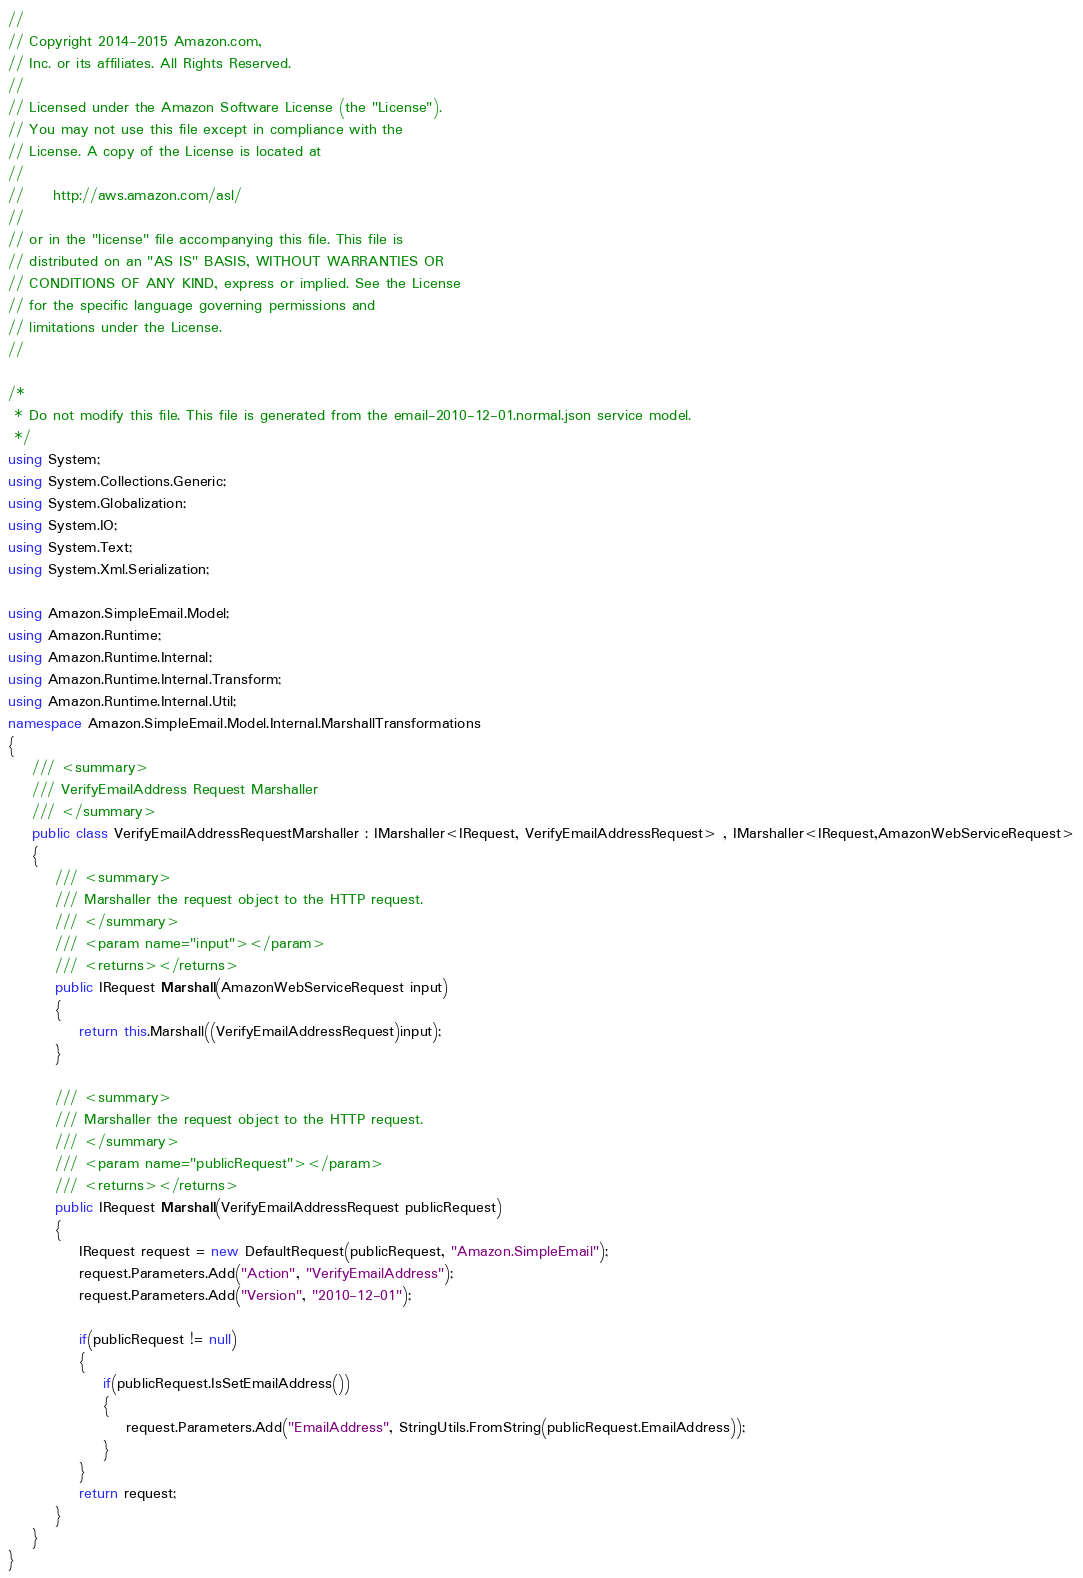Convert code to text. <code><loc_0><loc_0><loc_500><loc_500><_C#_>//
// Copyright 2014-2015 Amazon.com, 
// Inc. or its affiliates. All Rights Reserved.
// 
// Licensed under the Amazon Software License (the "License"). 
// You may not use this file except in compliance with the 
// License. A copy of the License is located at
// 
//     http://aws.amazon.com/asl/
// 
// or in the "license" file accompanying this file. This file is 
// distributed on an "AS IS" BASIS, WITHOUT WARRANTIES OR 
// CONDITIONS OF ANY KIND, express or implied. See the License 
// for the specific language governing permissions and 
// limitations under the License.
//

/*
 * Do not modify this file. This file is generated from the email-2010-12-01.normal.json service model.
 */
using System;
using System.Collections.Generic;
using System.Globalization;
using System.IO;
using System.Text;
using System.Xml.Serialization;

using Amazon.SimpleEmail.Model;
using Amazon.Runtime;
using Amazon.Runtime.Internal;
using Amazon.Runtime.Internal.Transform;
using Amazon.Runtime.Internal.Util;
namespace Amazon.SimpleEmail.Model.Internal.MarshallTransformations
{
    /// <summary>
    /// VerifyEmailAddress Request Marshaller
    /// </summary>       
    public class VerifyEmailAddressRequestMarshaller : IMarshaller<IRequest, VerifyEmailAddressRequest> , IMarshaller<IRequest,AmazonWebServiceRequest>
    {
        /// <summary>
        /// Marshaller the request object to the HTTP request.
        /// </summary>  
        /// <param name="input"></param>
        /// <returns></returns>
        public IRequest Marshall(AmazonWebServiceRequest input)
        {
            return this.Marshall((VerifyEmailAddressRequest)input);
        }
    
        /// <summary>
        /// Marshaller the request object to the HTTP request.
        /// </summary>  
        /// <param name="publicRequest"></param>
        /// <returns></returns>
        public IRequest Marshall(VerifyEmailAddressRequest publicRequest)
        {
            IRequest request = new DefaultRequest(publicRequest, "Amazon.SimpleEmail");
            request.Parameters.Add("Action", "VerifyEmailAddress");
            request.Parameters.Add("Version", "2010-12-01");

            if(publicRequest != null)
            {
                if(publicRequest.IsSetEmailAddress())
                {
                    request.Parameters.Add("EmailAddress", StringUtils.FromString(publicRequest.EmailAddress));
                }
            }
            return request;
        }
    }
}</code> 